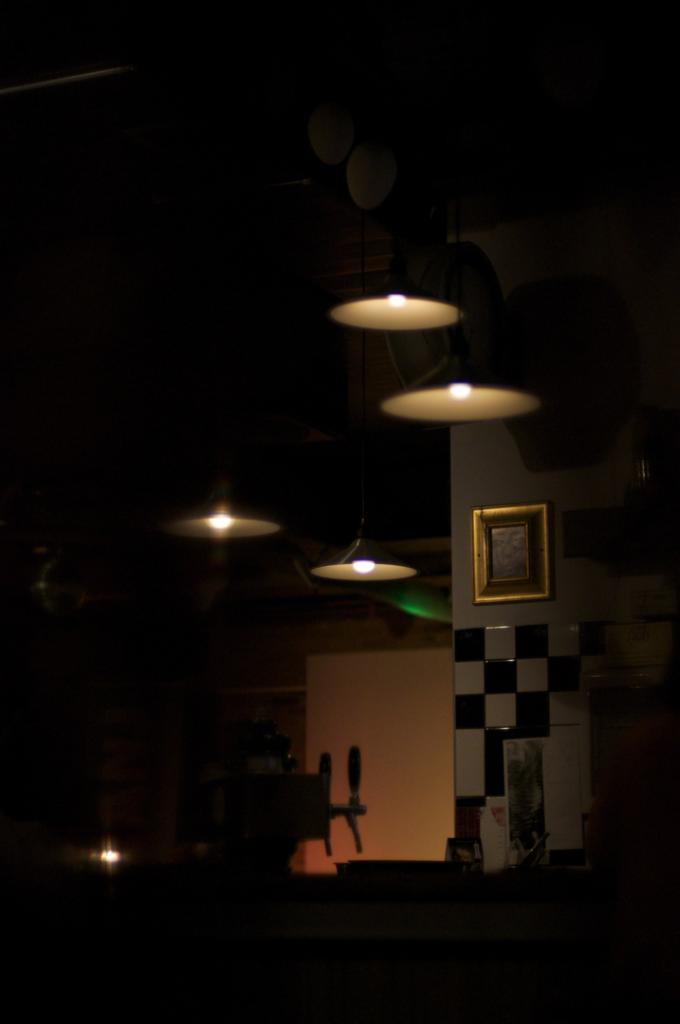What type of space is shown in the image? The image is an inside view of a room. What can be seen in the room that provides illumination? There are lights in the room. What type of decorative item is present in the room? There is a photo frame in the room. What can be seen on the walls of the room? The walls of the room are visible. What type of flooring is present in the room? Tiles are present in the room. What else can be found in the room besides the lights, photo frame, and walls? There are objects in the room. How does the desk in the room act as a support for the seat? There is no desk or seat present in the image; the conversation focuses on the room's features and contents. 